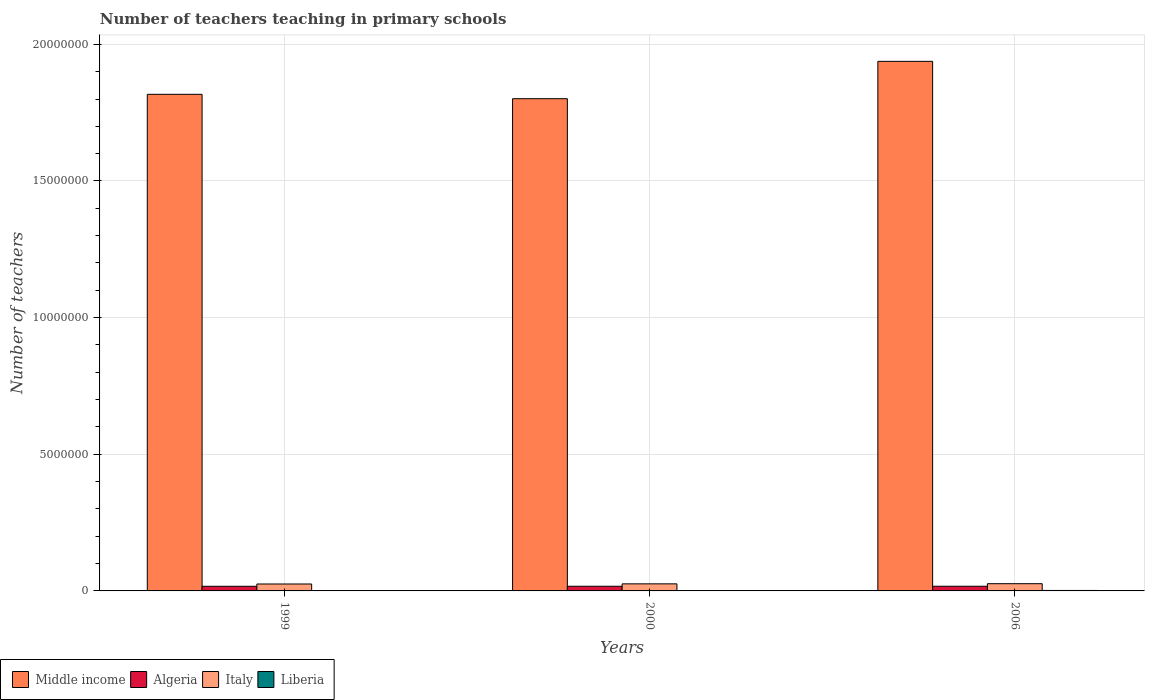How many different coloured bars are there?
Provide a succinct answer. 4. Are the number of bars on each tick of the X-axis equal?
Provide a short and direct response. Yes. How many bars are there on the 1st tick from the left?
Make the answer very short. 4. How many bars are there on the 3rd tick from the right?
Make the answer very short. 4. What is the label of the 3rd group of bars from the left?
Ensure brevity in your answer.  2006. What is the number of teachers teaching in primary schools in Liberia in 2006?
Your answer should be compact. 1.75e+04. Across all years, what is the maximum number of teachers teaching in primary schools in Algeria?
Make the answer very short. 1.71e+05. Across all years, what is the minimum number of teachers teaching in primary schools in Liberia?
Provide a short and direct response. 1.01e+04. In which year was the number of teachers teaching in primary schools in Italy maximum?
Your response must be concise. 2006. In which year was the number of teachers teaching in primary schools in Italy minimum?
Provide a succinct answer. 1999. What is the total number of teachers teaching in primary schools in Middle income in the graph?
Make the answer very short. 5.56e+07. What is the difference between the number of teachers teaching in primary schools in Italy in 1999 and that in 2000?
Make the answer very short. -5091. What is the difference between the number of teachers teaching in primary schools in Middle income in 2000 and the number of teachers teaching in primary schools in Italy in 1999?
Your answer should be compact. 1.78e+07. What is the average number of teachers teaching in primary schools in Algeria per year?
Make the answer very short. 1.70e+05. In the year 1999, what is the difference between the number of teachers teaching in primary schools in Middle income and number of teachers teaching in primary schools in Italy?
Provide a succinct answer. 1.79e+07. What is the ratio of the number of teachers teaching in primary schools in Italy in 1999 to that in 2000?
Offer a terse response. 0.98. Is the number of teachers teaching in primary schools in Algeria in 1999 less than that in 2000?
Your response must be concise. Yes. What is the difference between the highest and the second highest number of teachers teaching in primary schools in Algeria?
Provide a succinct answer. 840. What is the difference between the highest and the lowest number of teachers teaching in primary schools in Liberia?
Provide a succinct answer. 7405. In how many years, is the number of teachers teaching in primary schools in Middle income greater than the average number of teachers teaching in primary schools in Middle income taken over all years?
Offer a terse response. 1. Is the sum of the number of teachers teaching in primary schools in Algeria in 1999 and 2000 greater than the maximum number of teachers teaching in primary schools in Middle income across all years?
Provide a short and direct response. No. What does the 4th bar from the left in 1999 represents?
Provide a succinct answer. Liberia. What does the 2nd bar from the right in 1999 represents?
Make the answer very short. Italy. Is it the case that in every year, the sum of the number of teachers teaching in primary schools in Liberia and number of teachers teaching in primary schools in Algeria is greater than the number of teachers teaching in primary schools in Italy?
Ensure brevity in your answer.  No. How many bars are there?
Offer a very short reply. 12. Are the values on the major ticks of Y-axis written in scientific E-notation?
Your response must be concise. No. Where does the legend appear in the graph?
Give a very brief answer. Bottom left. What is the title of the graph?
Offer a very short reply. Number of teachers teaching in primary schools. Does "Iceland" appear as one of the legend labels in the graph?
Keep it short and to the point. No. What is the label or title of the Y-axis?
Your answer should be very brief. Number of teachers. What is the Number of teachers in Middle income in 1999?
Your answer should be very brief. 1.82e+07. What is the Number of teachers of Algeria in 1999?
Your answer should be compact. 1.70e+05. What is the Number of teachers in Italy in 1999?
Your answer should be very brief. 2.54e+05. What is the Number of teachers in Liberia in 1999?
Ensure brevity in your answer.  1.01e+04. What is the Number of teachers in Middle income in 2000?
Provide a short and direct response. 1.80e+07. What is the Number of teachers in Algeria in 2000?
Your answer should be very brief. 1.71e+05. What is the Number of teachers in Italy in 2000?
Your answer should be very brief. 2.59e+05. What is the Number of teachers in Liberia in 2000?
Offer a very short reply. 1.30e+04. What is the Number of teachers in Middle income in 2006?
Offer a terse response. 1.94e+07. What is the Number of teachers of Algeria in 2006?
Give a very brief answer. 1.71e+05. What is the Number of teachers in Italy in 2006?
Your answer should be compact. 2.64e+05. What is the Number of teachers in Liberia in 2006?
Provide a short and direct response. 1.75e+04. Across all years, what is the maximum Number of teachers of Middle income?
Give a very brief answer. 1.94e+07. Across all years, what is the maximum Number of teachers in Algeria?
Your answer should be compact. 1.71e+05. Across all years, what is the maximum Number of teachers in Italy?
Your response must be concise. 2.64e+05. Across all years, what is the maximum Number of teachers of Liberia?
Keep it short and to the point. 1.75e+04. Across all years, what is the minimum Number of teachers in Middle income?
Ensure brevity in your answer.  1.80e+07. Across all years, what is the minimum Number of teachers in Algeria?
Offer a terse response. 1.70e+05. Across all years, what is the minimum Number of teachers in Italy?
Your answer should be compact. 2.54e+05. Across all years, what is the minimum Number of teachers in Liberia?
Provide a short and direct response. 1.01e+04. What is the total Number of teachers in Middle income in the graph?
Offer a terse response. 5.56e+07. What is the total Number of teachers of Algeria in the graph?
Offer a very short reply. 5.11e+05. What is the total Number of teachers in Italy in the graph?
Keep it short and to the point. 7.77e+05. What is the total Number of teachers in Liberia in the graph?
Your response must be concise. 4.05e+04. What is the difference between the Number of teachers in Middle income in 1999 and that in 2000?
Ensure brevity in your answer.  1.60e+05. What is the difference between the Number of teachers in Algeria in 1999 and that in 2000?
Your answer should be very brief. -1043. What is the difference between the Number of teachers in Italy in 1999 and that in 2000?
Offer a very short reply. -5091. What is the difference between the Number of teachers of Liberia in 1999 and that in 2000?
Provide a short and direct response. -2911. What is the difference between the Number of teachers in Middle income in 1999 and that in 2006?
Keep it short and to the point. -1.21e+06. What is the difference between the Number of teachers of Algeria in 1999 and that in 2006?
Offer a very short reply. -1883. What is the difference between the Number of teachers in Italy in 1999 and that in 2006?
Keep it short and to the point. -1.06e+04. What is the difference between the Number of teachers of Liberia in 1999 and that in 2006?
Make the answer very short. -7405. What is the difference between the Number of teachers in Middle income in 2000 and that in 2006?
Give a very brief answer. -1.37e+06. What is the difference between the Number of teachers in Algeria in 2000 and that in 2006?
Offer a terse response. -840. What is the difference between the Number of teachers in Italy in 2000 and that in 2006?
Keep it short and to the point. -5551. What is the difference between the Number of teachers in Liberia in 2000 and that in 2006?
Ensure brevity in your answer.  -4494. What is the difference between the Number of teachers in Middle income in 1999 and the Number of teachers in Algeria in 2000?
Your answer should be very brief. 1.80e+07. What is the difference between the Number of teachers of Middle income in 1999 and the Number of teachers of Italy in 2000?
Keep it short and to the point. 1.79e+07. What is the difference between the Number of teachers of Middle income in 1999 and the Number of teachers of Liberia in 2000?
Ensure brevity in your answer.  1.82e+07. What is the difference between the Number of teachers in Algeria in 1999 and the Number of teachers in Italy in 2000?
Make the answer very short. -8.93e+04. What is the difference between the Number of teachers in Algeria in 1999 and the Number of teachers in Liberia in 2000?
Your response must be concise. 1.57e+05. What is the difference between the Number of teachers in Italy in 1999 and the Number of teachers in Liberia in 2000?
Provide a short and direct response. 2.41e+05. What is the difference between the Number of teachers in Middle income in 1999 and the Number of teachers in Algeria in 2006?
Keep it short and to the point. 1.80e+07. What is the difference between the Number of teachers in Middle income in 1999 and the Number of teachers in Italy in 2006?
Provide a succinct answer. 1.79e+07. What is the difference between the Number of teachers of Middle income in 1999 and the Number of teachers of Liberia in 2006?
Offer a very short reply. 1.82e+07. What is the difference between the Number of teachers in Algeria in 1999 and the Number of teachers in Italy in 2006?
Ensure brevity in your answer.  -9.49e+04. What is the difference between the Number of teachers in Algeria in 1999 and the Number of teachers in Liberia in 2006?
Make the answer very short. 1.52e+05. What is the difference between the Number of teachers in Italy in 1999 and the Number of teachers in Liberia in 2006?
Keep it short and to the point. 2.36e+05. What is the difference between the Number of teachers of Middle income in 2000 and the Number of teachers of Algeria in 2006?
Ensure brevity in your answer.  1.78e+07. What is the difference between the Number of teachers in Middle income in 2000 and the Number of teachers in Italy in 2006?
Your answer should be very brief. 1.77e+07. What is the difference between the Number of teachers of Middle income in 2000 and the Number of teachers of Liberia in 2006?
Ensure brevity in your answer.  1.80e+07. What is the difference between the Number of teachers in Algeria in 2000 and the Number of teachers in Italy in 2006?
Offer a terse response. -9.38e+04. What is the difference between the Number of teachers in Algeria in 2000 and the Number of teachers in Liberia in 2006?
Ensure brevity in your answer.  1.53e+05. What is the difference between the Number of teachers in Italy in 2000 and the Number of teachers in Liberia in 2006?
Your answer should be very brief. 2.41e+05. What is the average Number of teachers of Middle income per year?
Your answer should be very brief. 1.85e+07. What is the average Number of teachers in Algeria per year?
Provide a short and direct response. 1.70e+05. What is the average Number of teachers in Italy per year?
Make the answer very short. 2.59e+05. What is the average Number of teachers of Liberia per year?
Offer a terse response. 1.35e+04. In the year 1999, what is the difference between the Number of teachers in Middle income and Number of teachers in Algeria?
Offer a terse response. 1.80e+07. In the year 1999, what is the difference between the Number of teachers in Middle income and Number of teachers in Italy?
Keep it short and to the point. 1.79e+07. In the year 1999, what is the difference between the Number of teachers of Middle income and Number of teachers of Liberia?
Your answer should be compact. 1.82e+07. In the year 1999, what is the difference between the Number of teachers of Algeria and Number of teachers of Italy?
Provide a short and direct response. -8.42e+04. In the year 1999, what is the difference between the Number of teachers in Algeria and Number of teachers in Liberia?
Make the answer very short. 1.59e+05. In the year 1999, what is the difference between the Number of teachers in Italy and Number of teachers in Liberia?
Keep it short and to the point. 2.44e+05. In the year 2000, what is the difference between the Number of teachers of Middle income and Number of teachers of Algeria?
Ensure brevity in your answer.  1.78e+07. In the year 2000, what is the difference between the Number of teachers of Middle income and Number of teachers of Italy?
Offer a terse response. 1.78e+07. In the year 2000, what is the difference between the Number of teachers of Middle income and Number of teachers of Liberia?
Provide a short and direct response. 1.80e+07. In the year 2000, what is the difference between the Number of teachers in Algeria and Number of teachers in Italy?
Keep it short and to the point. -8.83e+04. In the year 2000, what is the difference between the Number of teachers in Algeria and Number of teachers in Liberia?
Your answer should be very brief. 1.58e+05. In the year 2000, what is the difference between the Number of teachers of Italy and Number of teachers of Liberia?
Your response must be concise. 2.46e+05. In the year 2006, what is the difference between the Number of teachers in Middle income and Number of teachers in Algeria?
Keep it short and to the point. 1.92e+07. In the year 2006, what is the difference between the Number of teachers in Middle income and Number of teachers in Italy?
Ensure brevity in your answer.  1.91e+07. In the year 2006, what is the difference between the Number of teachers of Middle income and Number of teachers of Liberia?
Provide a succinct answer. 1.94e+07. In the year 2006, what is the difference between the Number of teachers of Algeria and Number of teachers of Italy?
Make the answer very short. -9.30e+04. In the year 2006, what is the difference between the Number of teachers in Algeria and Number of teachers in Liberia?
Ensure brevity in your answer.  1.54e+05. In the year 2006, what is the difference between the Number of teachers of Italy and Number of teachers of Liberia?
Make the answer very short. 2.47e+05. What is the ratio of the Number of teachers in Middle income in 1999 to that in 2000?
Your response must be concise. 1.01. What is the ratio of the Number of teachers of Italy in 1999 to that in 2000?
Provide a succinct answer. 0.98. What is the ratio of the Number of teachers in Liberia in 1999 to that in 2000?
Your response must be concise. 0.78. What is the ratio of the Number of teachers in Middle income in 1999 to that in 2006?
Your answer should be compact. 0.94. What is the ratio of the Number of teachers of Algeria in 1999 to that in 2006?
Your answer should be compact. 0.99. What is the ratio of the Number of teachers of Italy in 1999 to that in 2006?
Keep it short and to the point. 0.96. What is the ratio of the Number of teachers in Liberia in 1999 to that in 2006?
Give a very brief answer. 0.58. What is the ratio of the Number of teachers in Middle income in 2000 to that in 2006?
Offer a terse response. 0.93. What is the ratio of the Number of teachers of Italy in 2000 to that in 2006?
Keep it short and to the point. 0.98. What is the ratio of the Number of teachers of Liberia in 2000 to that in 2006?
Your answer should be compact. 0.74. What is the difference between the highest and the second highest Number of teachers of Middle income?
Keep it short and to the point. 1.21e+06. What is the difference between the highest and the second highest Number of teachers of Algeria?
Make the answer very short. 840. What is the difference between the highest and the second highest Number of teachers in Italy?
Make the answer very short. 5551. What is the difference between the highest and the second highest Number of teachers of Liberia?
Provide a succinct answer. 4494. What is the difference between the highest and the lowest Number of teachers in Middle income?
Make the answer very short. 1.37e+06. What is the difference between the highest and the lowest Number of teachers of Algeria?
Keep it short and to the point. 1883. What is the difference between the highest and the lowest Number of teachers in Italy?
Your answer should be compact. 1.06e+04. What is the difference between the highest and the lowest Number of teachers in Liberia?
Ensure brevity in your answer.  7405. 